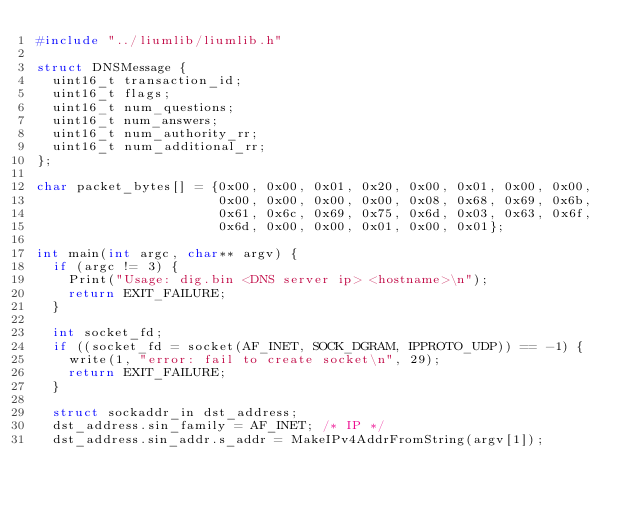<code> <loc_0><loc_0><loc_500><loc_500><_C_>#include "../liumlib/liumlib.h"

struct DNSMessage {
  uint16_t transaction_id;
  uint16_t flags;
  uint16_t num_questions;
  uint16_t num_answers;
  uint16_t num_authority_rr;
  uint16_t num_additional_rr;
};

char packet_bytes[] = {0x00, 0x00, 0x01, 0x20, 0x00, 0x01, 0x00, 0x00,
                       0x00, 0x00, 0x00, 0x00, 0x08, 0x68, 0x69, 0x6b,
                       0x61, 0x6c, 0x69, 0x75, 0x6d, 0x03, 0x63, 0x6f,
                       0x6d, 0x00, 0x00, 0x01, 0x00, 0x01};

int main(int argc, char** argv) {
  if (argc != 3) {
    Print("Usage: dig.bin <DNS server ip> <hostname>\n");
    return EXIT_FAILURE;
  }

  int socket_fd;
  if ((socket_fd = socket(AF_INET, SOCK_DGRAM, IPPROTO_UDP)) == -1) {
    write(1, "error: fail to create socket\n", 29);
    return EXIT_FAILURE;
  }

  struct sockaddr_in dst_address;
  dst_address.sin_family = AF_INET; /* IP */
  dst_address.sin_addr.s_addr = MakeIPv4AddrFromString(argv[1]);</code> 